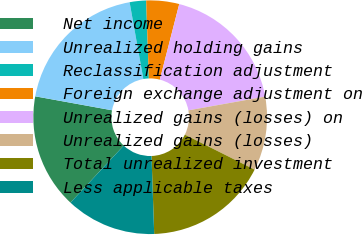Convert chart to OTSL. <chart><loc_0><loc_0><loc_500><loc_500><pie_chart><fcel>Net income<fcel>Unrealized holding gains<fcel>Reclassification adjustment<fcel>Foreign exchange adjustment on<fcel>Unrealized gains (losses) on<fcel>Unrealized gains (losses)<fcel>Total unrealized investment<fcel>Less applicable taxes<nl><fcel>15.91%<fcel>19.32%<fcel>2.27%<fcel>4.55%<fcel>18.18%<fcel>10.23%<fcel>17.05%<fcel>12.5%<nl></chart> 